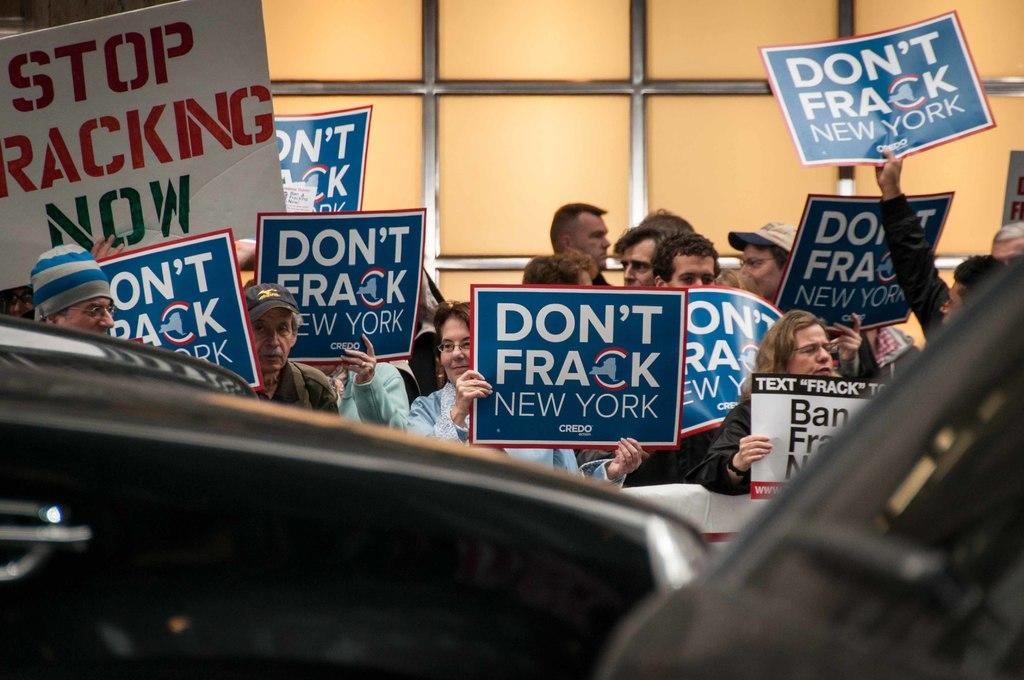What is the main subject of the image? The main subject of the image is a group of people. What are the people holding in the image? The people are holding posters in the image. What other object can be seen in the image besides the people and posters? There is a white board in the image. Can you describe the vehicle visible in the image? The vehicle is visible in the image, but its specific details are not mentioned in the facts provided. How many fish are swimming in the top of the white board in the image? There are no fish present in the image, and the white board is not described as having a top or being related to water. 